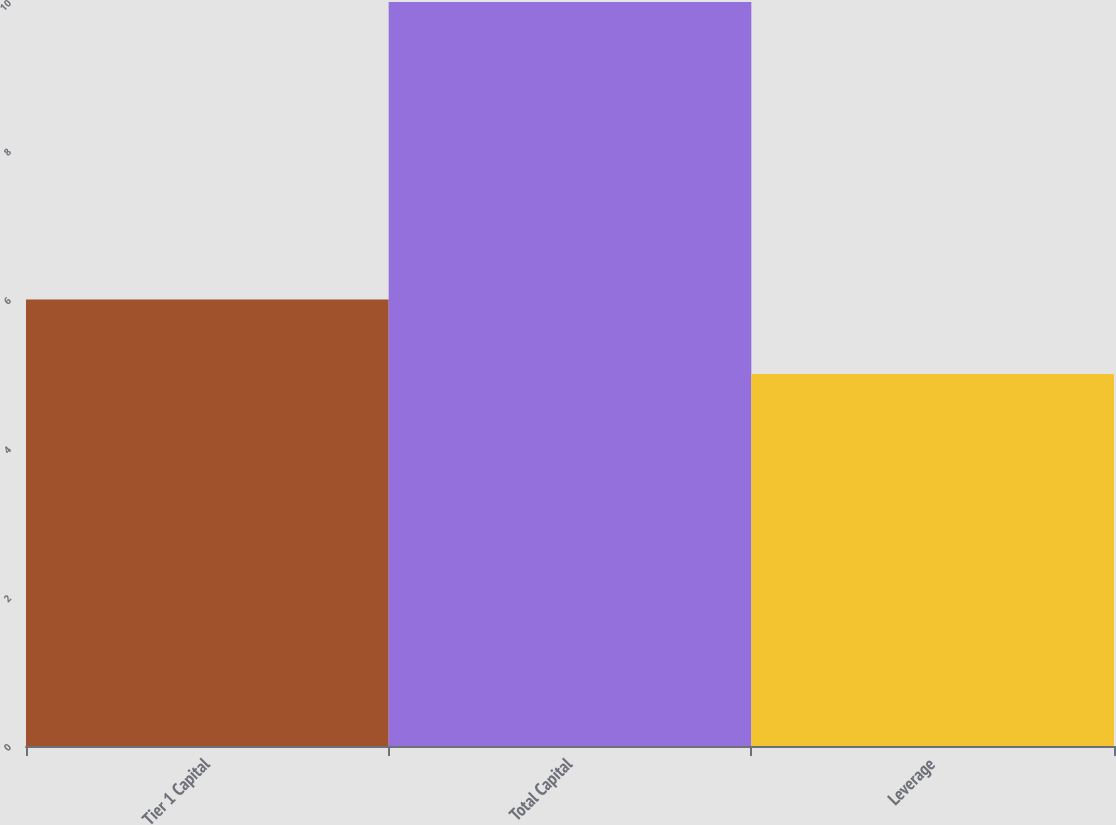<chart> <loc_0><loc_0><loc_500><loc_500><bar_chart><fcel>Tier 1 Capital<fcel>Total Capital<fcel>Leverage<nl><fcel>6<fcel>10<fcel>5<nl></chart> 